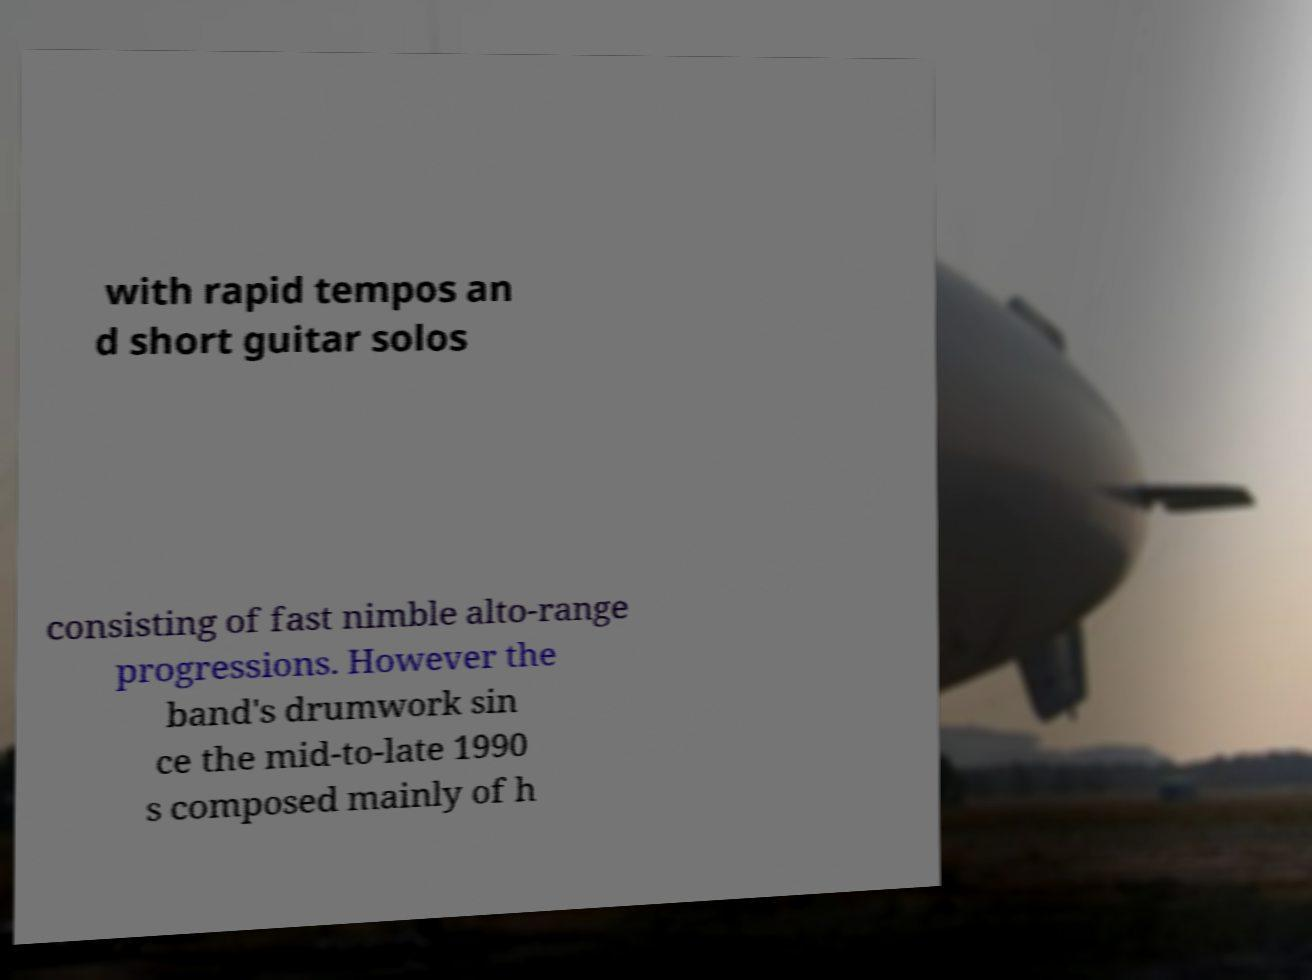For documentation purposes, I need the text within this image transcribed. Could you provide that? with rapid tempos an d short guitar solos consisting of fast nimble alto-range progressions. However the band's drumwork sin ce the mid-to-late 1990 s composed mainly of h 